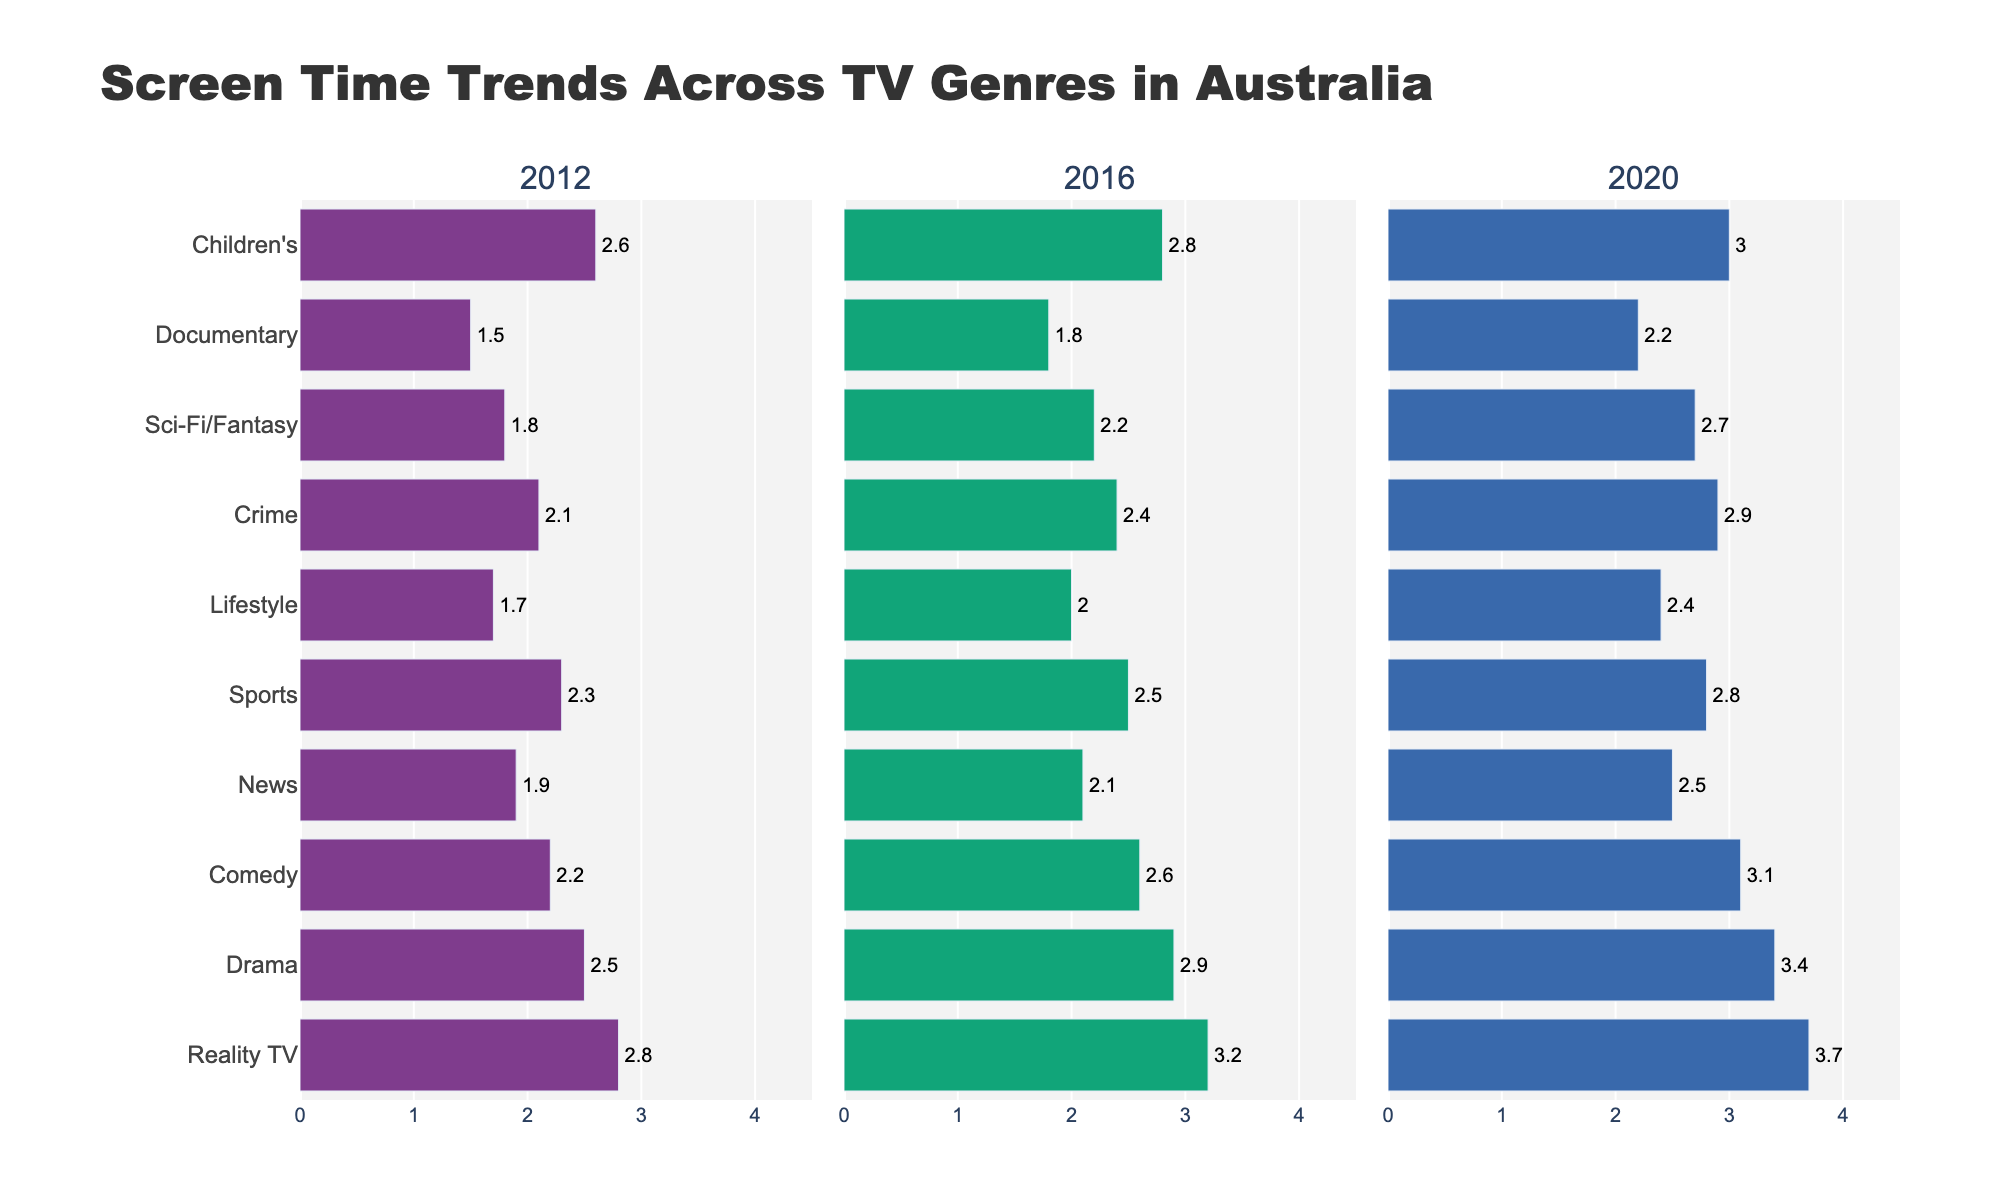What genre saw the largest increase in screen time from 2012 to 2020? To find the genre with the largest increase in screen time, calculate the difference in screen time for each genre between 2012 and 2020 and then compare these differences. For Reality TV, the increase is 3.7 - 2.8 = 0.9 hours. For Drama, it's 3.4 - 2.5 = 0.9 hours. For Comedy, it's 3.1 - 2.2 = 0.9 hours. For News, it's 2.5 - 1.9 = 0.6 hours. For Sports, it's 2.8 - 2.3 = 0.5 hours. For Lifestyle, it's 2.4 - 1.7 = 0.7 hours. For Crime, it's 2.9 - 2.1 = 0.8 hours. For Sci-Fi/Fantasy, it's 2.7 - 1.8 = 0.9 hours. For Documentary, it's 2.2 - 1.5 = 0.7 hours. For Children's, it's 3.0 - 2.6 = 0.4 hours. Reality TV, Drama, Comedy, and Sci-Fi/Fantasy all saw the largest increase of 0.9 hours.
Answer: Reality TV, Drama, Comedy, and Sci-Fi/Fantasy Which genre had the lowest screen time in 2012, and what was its value? Identify the genre with the smallest bar in the 2012 data segment. Documentary has the shortest bar in 2012, corresponding to 1.5 hours of screen time.
Answer: Documentary, 1.5 hours How did the screen time for News change between 2012 and 2020? Look at the screen time values for News in 2012 and 2020. In 2012, News had 1.9 hours, and in 2020 it had 2.5 hours. Calculate the difference. The change is 2.5 - 1.9 = 0.6 hours.
Answer: Increased by 0.6 hours What is the total screen time for Comedy across all years shown? Sum the screen time values for Comedy in 2012, 2016, and 2020. The values are 2.2, 2.6, and 3.1 hours. Adding them gives 2.2 + 2.6 + 3.1 = 7.9 hours.
Answer: 7.9 hours Which genres have a screen time of 2.4 hours in any of the years shown? Identify genres that have a bar that reaches the 2.4-hour mark in any of the years. Crime and Lifestyle recorded 2.4 hours in different years.
Answer: Crime, Lifestyle Compare the screen time trend of Drama and Sports from 2012 to 2020. Look at the screen time values for Drama and Sports in 2012, 2016, and 2020. For Drama, the values are 2.5, 2.9, and 3.4. For Sports, the values are 2.3, 2.5, and 2.8. Both genres increased over the years, but Drama’s increase is greater. Drama increased by 0.9 hours from 2.5 to 3.4, while Sports increased by 0.5 hours from 2.3 to 2.8.
Answer: Drama increased more than Sports Which genre had a screen time of 2.8 hours in 2020? Find the genre that has a bar extending to 2.8 hours in the 2020 segment. Sports had a screen time of 2.8 hours in 2020.
Answer: Sports What was the average screen time for Children's TV across all the years shown? Calculate the average by adding the screen time values for Children's TV in 2012, 2016, and 2020, then divide by the number of years. The values are 2.6, 2.8, and 3.0 hours. The sum is 2.6 + 2.8 + 3.0 = 8.4 hours. Divide by 3 to get 8.4 / 3 = 2.8 hours.
Answer: 2.8 hours Which year had the highest screen time for Reality TV? Identify the bar that reaches the maximum height for Reality TV among 2012, 2016, and 2020. Reality TV had the highest screen time in 2020 with 3.7 hours.
Answer: 2020, 3.7 hours 